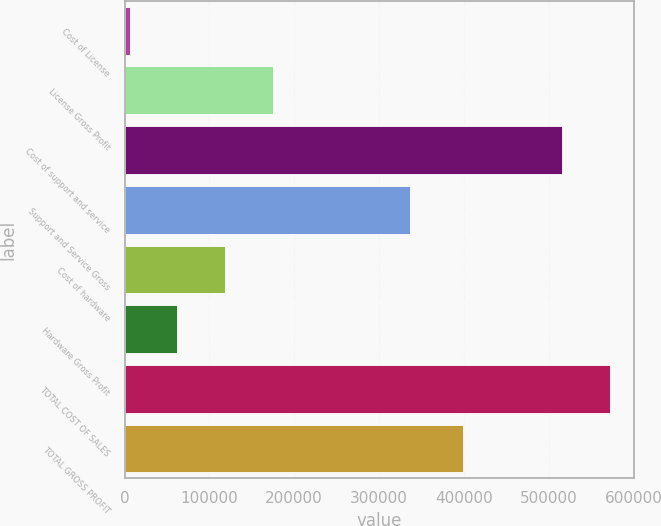Convert chart to OTSL. <chart><loc_0><loc_0><loc_500><loc_500><bar_chart><fcel>Cost of License<fcel>License Gross Profit<fcel>Cost of support and service<fcel>Support and Service Gross<fcel>Cost of hardware<fcel>Hardware Gross Profit<fcel>TOTAL COST OF SALES<fcel>TOTAL GROSS PROFIT<nl><fcel>6285<fcel>174668<fcel>515917<fcel>336336<fcel>118541<fcel>62412.8<fcel>572045<fcel>399334<nl></chart> 